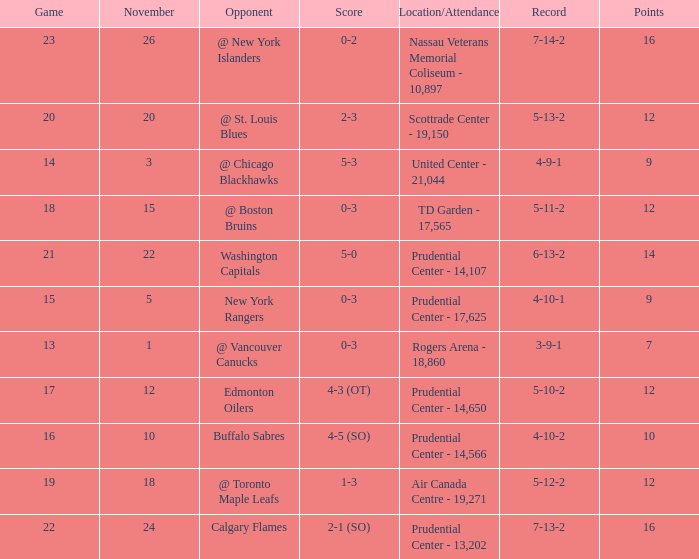Could you parse the entire table? {'header': ['Game', 'November', 'Opponent', 'Score', 'Location/Attendance', 'Record', 'Points'], 'rows': [['23', '26', '@ New York Islanders', '0-2', 'Nassau Veterans Memorial Coliseum - 10,897', '7-14-2', '16'], ['20', '20', '@ St. Louis Blues', '2-3', 'Scottrade Center - 19,150', '5-13-2', '12'], ['14', '3', '@ Chicago Blackhawks', '5-3', 'United Center - 21,044', '4-9-1', '9'], ['18', '15', '@ Boston Bruins', '0-3', 'TD Garden - 17,565', '5-11-2', '12'], ['21', '22', 'Washington Capitals', '5-0', 'Prudential Center - 14,107', '6-13-2', '14'], ['15', '5', 'New York Rangers', '0-3', 'Prudential Center - 17,625', '4-10-1', '9'], ['13', '1', '@ Vancouver Canucks', '0-3', 'Rogers Arena - 18,860', '3-9-1', '7'], ['17', '12', 'Edmonton Oilers', '4-3 (OT)', 'Prudential Center - 14,650', '5-10-2', '12'], ['16', '10', 'Buffalo Sabres', '4-5 (SO)', 'Prudential Center - 14,566', '4-10-2', '10'], ['19', '18', '@ Toronto Maple Leafs', '1-3', 'Air Canada Centre - 19,271', '5-12-2', '12'], ['22', '24', 'Calgary Flames', '2-1 (SO)', 'Prudential Center - 13,202', '7-13-2', '16']]} What is the maximum number of points? 16.0. 